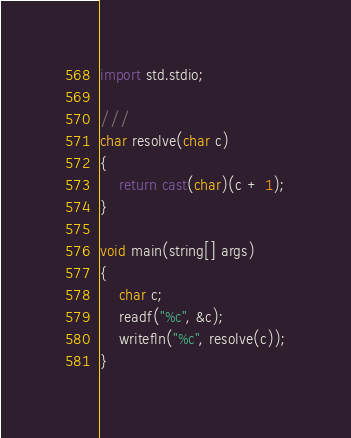Convert code to text. <code><loc_0><loc_0><loc_500><loc_500><_D_>import std.stdio;

///
char resolve(char c)
{
    return cast(char)(c + 1);
}

void main(string[] args)
{
    char c;
    readf("%c", &c);
    writefln("%c", resolve(c));
}</code> 